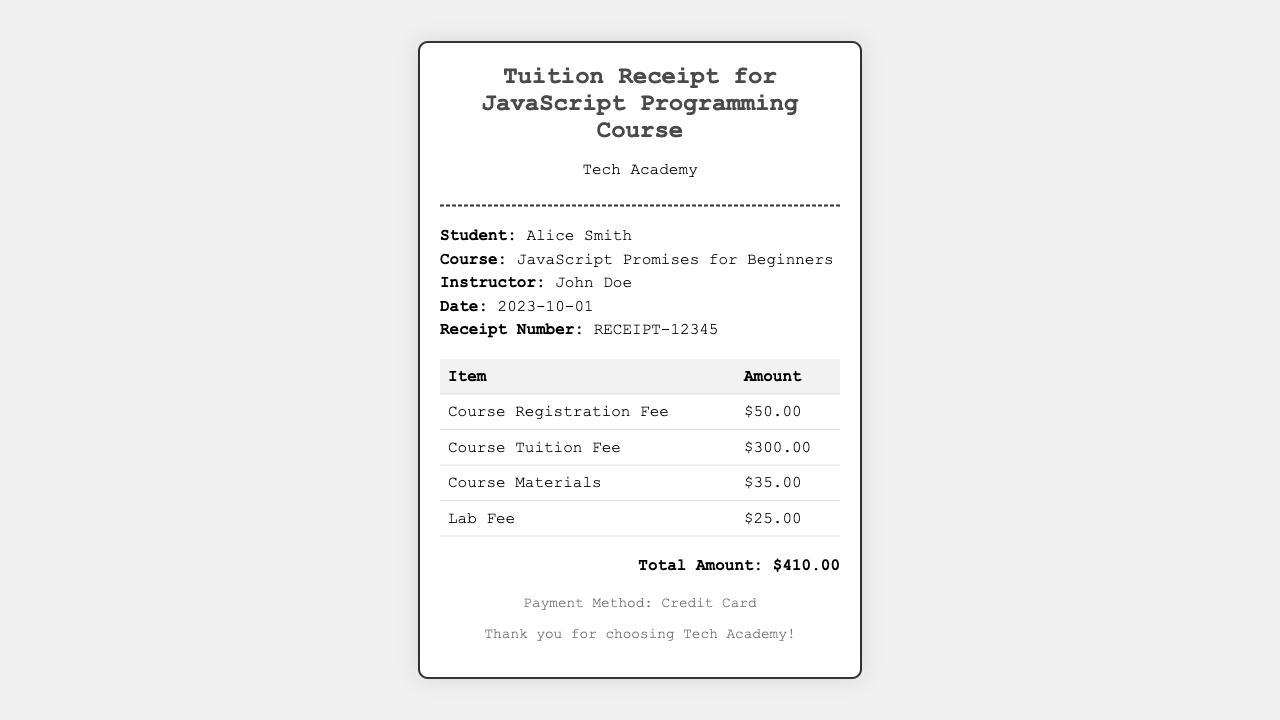What is the student's name? The student's name is explicitly stated in the document under the info section.
Answer: Alice Smith What is the date of the receipt? The date is mentioned in the info section of the receipt document.
Answer: 2023-10-01 What is the course title? The course title is indicated in the info section, related to the course taken by the student.
Answer: JavaScript Promises for Beginners How much is the Course Registration Fee? This amount is detailed in the breakdown table of the fees paid.
Answer: $50.00 What is the total amount? The total amount is calculated and presented in the total section at the bottom of the document.
Answer: $410.00 How much is the Lab Fee? The Lab Fee is specified in the breakdown table of the fees.
Answer: $25.00 Who is the instructor? The instructor's name is provided in the info section of the receipt.
Answer: John Doe What payment method was used? The payment method is mentioned in the footer section of the document.
Answer: Credit Card How much do course materials cost? The cost of course materials is provided in the fees breakdown table.
Answer: $35.00 